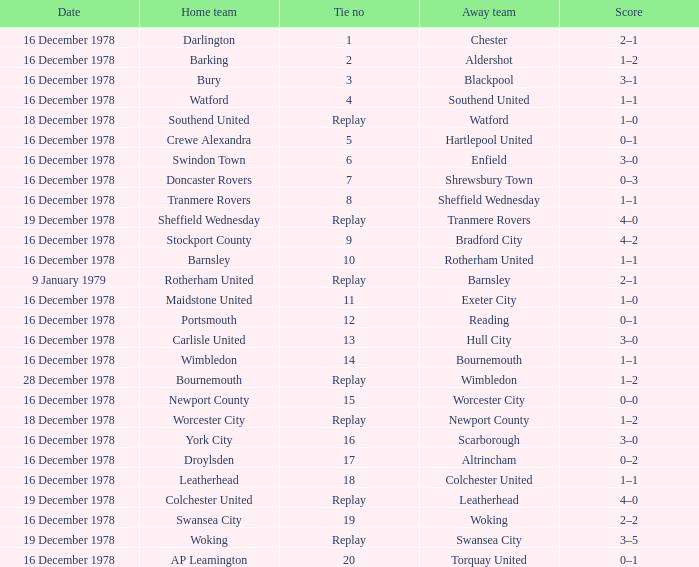What date had a tie no of replay, and an away team of watford? 18 December 1978. 